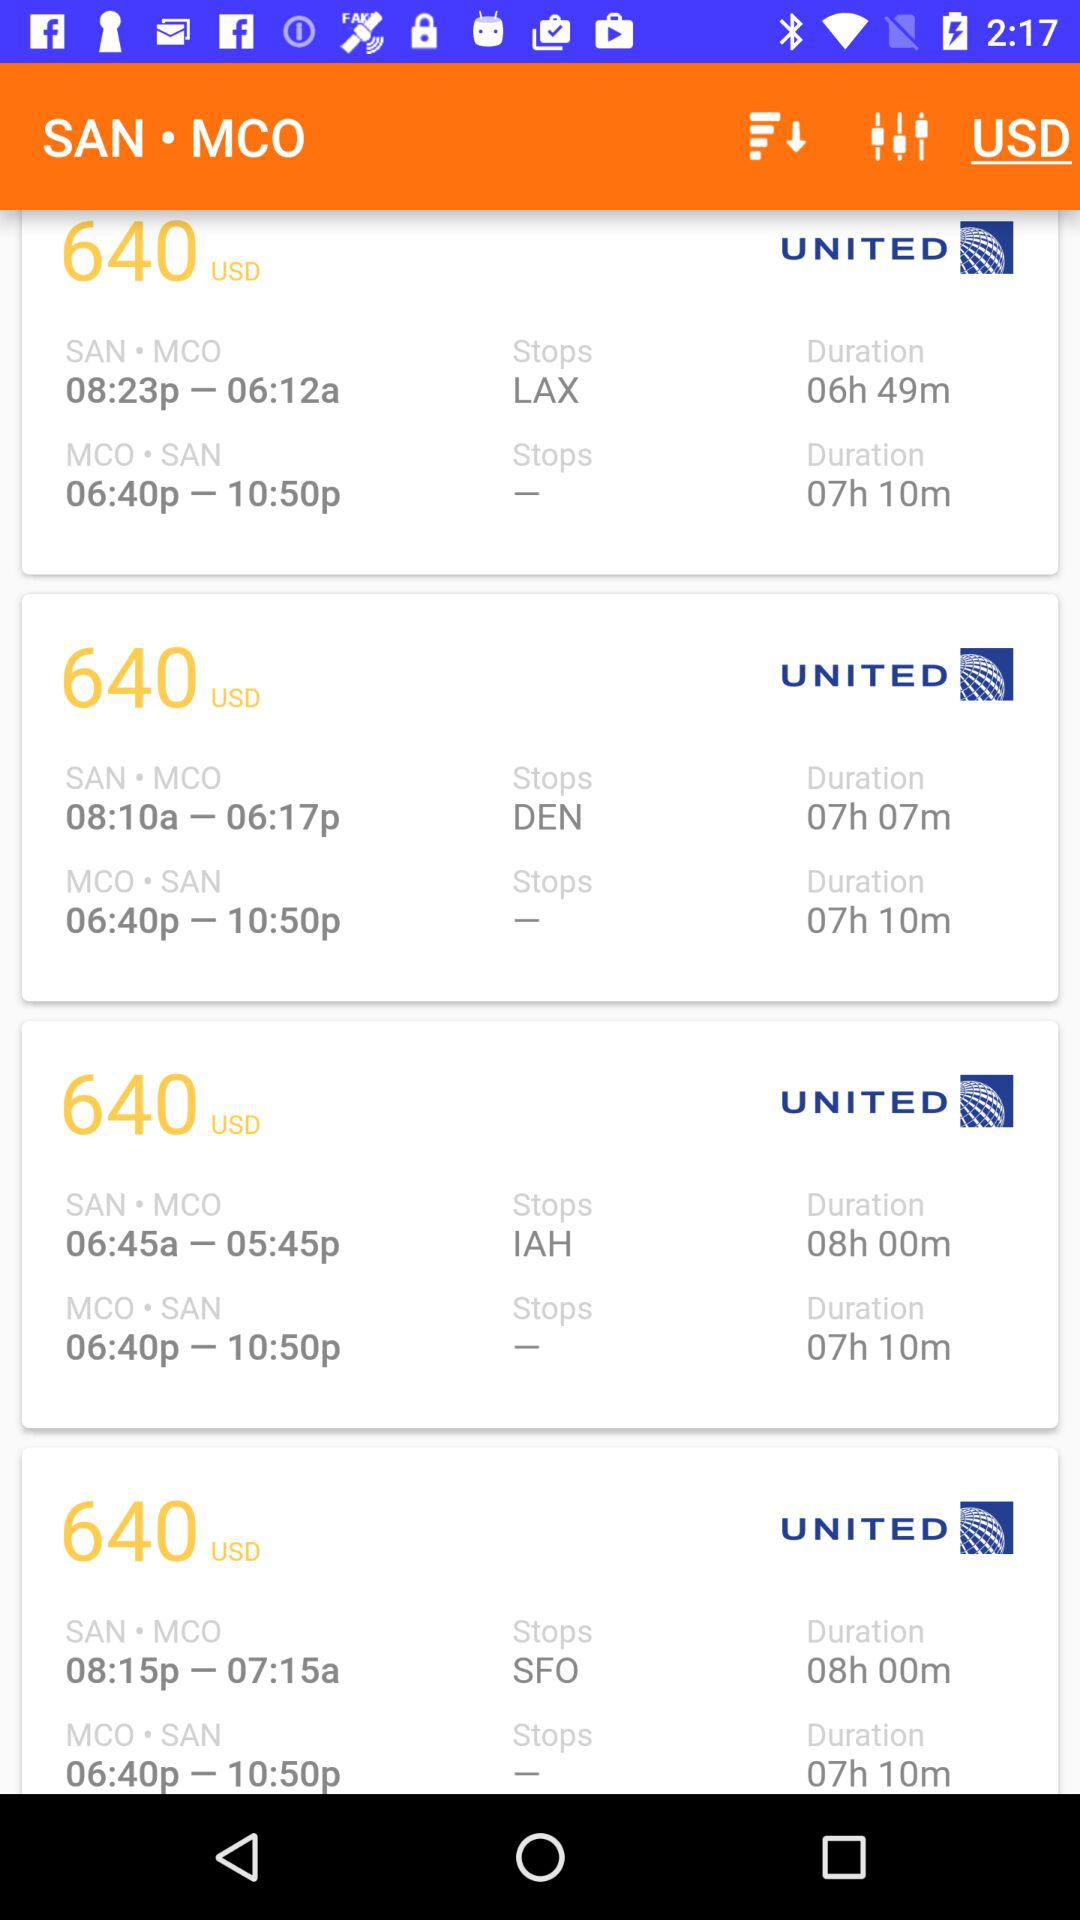How many flights are there from SAN to MCO?
Answer the question using a single word or phrase. 4 